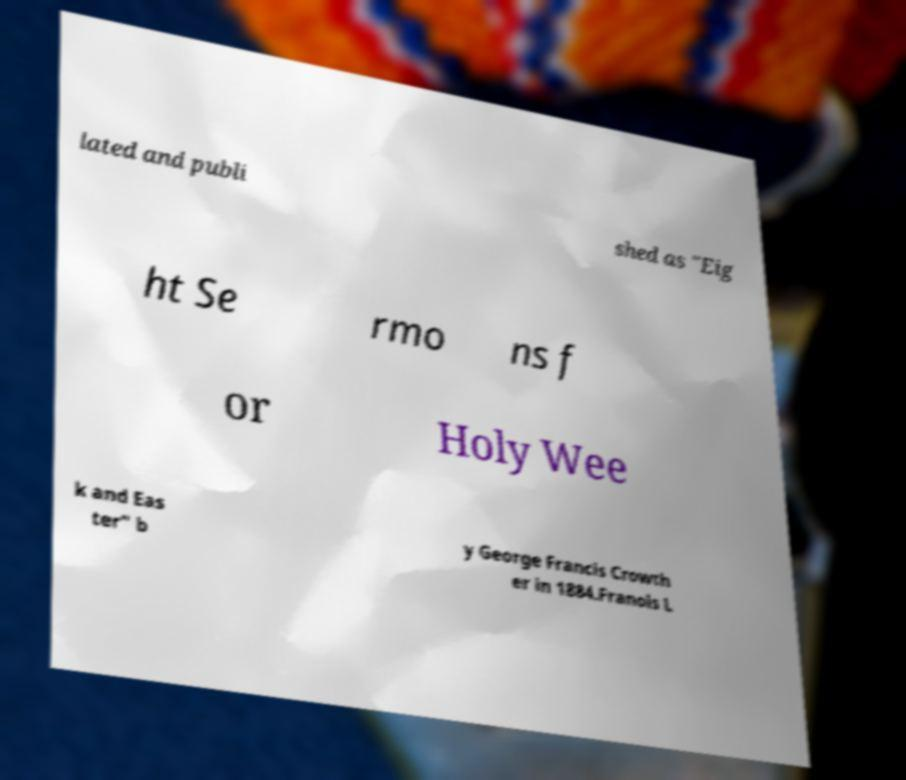I need the written content from this picture converted into text. Can you do that? lated and publi shed as "Eig ht Se rmo ns f or Holy Wee k and Eas ter" b y George Francis Crowth er in 1884.Franois L 